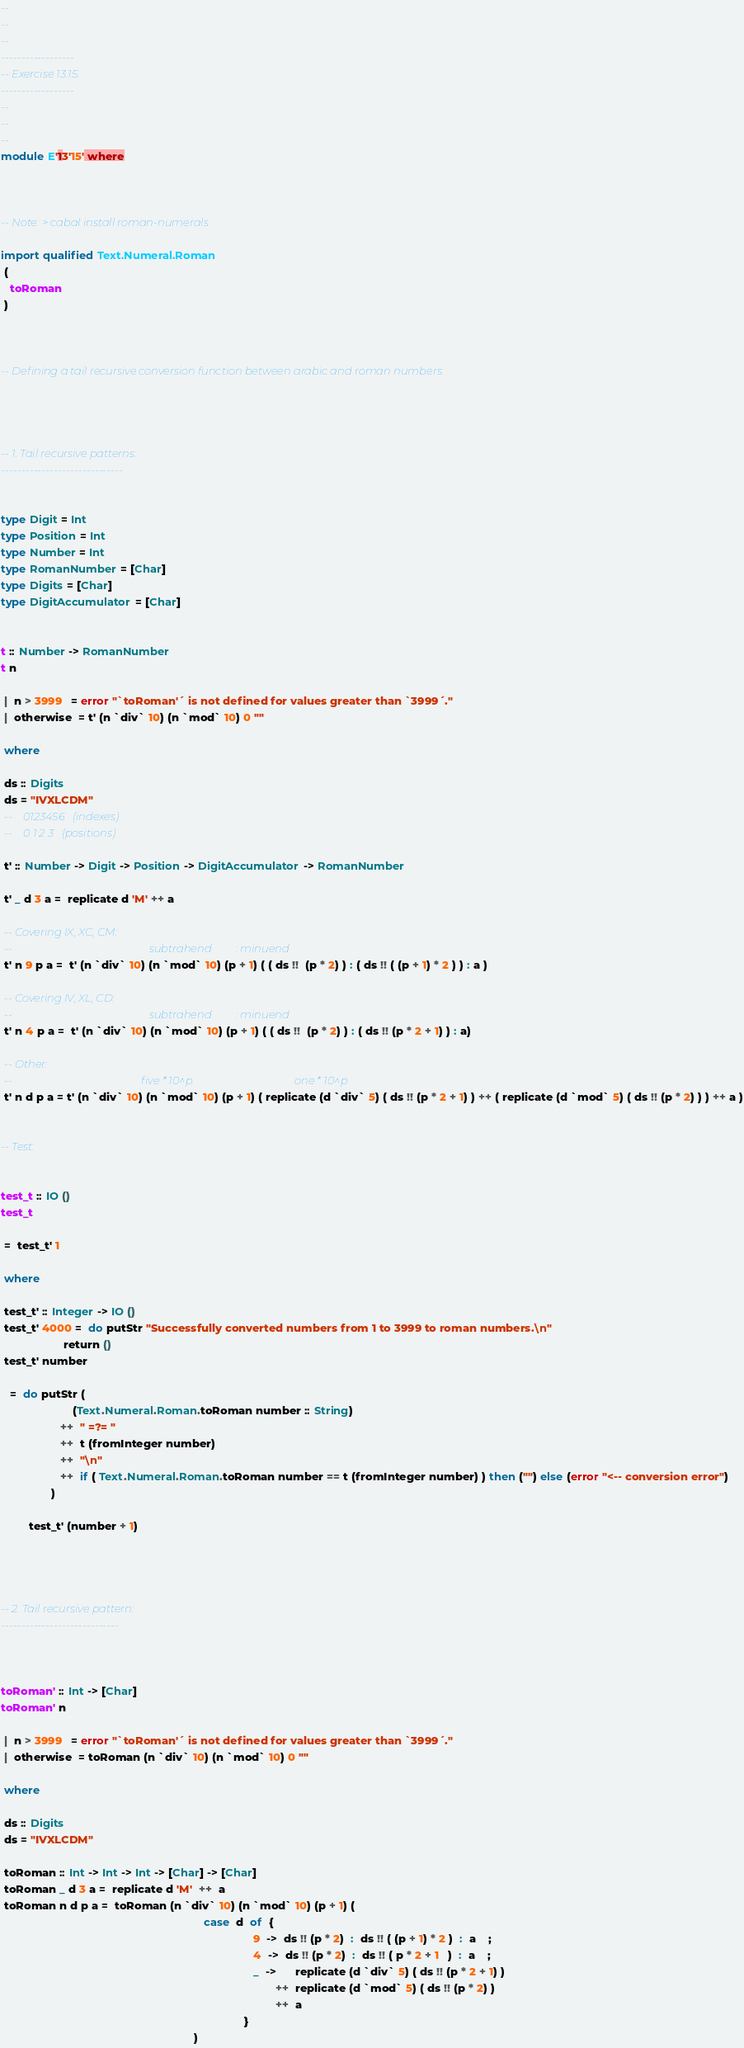<code> <loc_0><loc_0><loc_500><loc_500><_Haskell_>--
--
--
------------------
-- Exercise 13.15.
------------------
--
--
--
module E'13'15' where



-- Note: > cabal install roman-numerals

import qualified Text.Numeral.Roman
 (
   toRoman
 )



-- Defining a tail recursive conversion function between arabic and roman numbers.




-- 1. Tail recursive patterns:
------------------------------


type Digit = Int
type Position = Int
type Number = Int
type RomanNumber = [Char]
type Digits = [Char]
type DigitAccumulator = [Char]


t :: Number -> RomanNumber
t n

 |  n > 3999   = error "`toRoman'´ is not defined for values greater than `3999´."
 |  otherwise  = t' (n `div` 10) (n `mod` 10) 0 ""
 
 where
 
 ds :: Digits
 ds = "IVXLCDM"
 --    0123456   (indexes)
 --    0 1 2 3   (positions)
 
 t' :: Number -> Digit -> Position -> DigitAccumulator -> RomanNumber
 
 t' _ d 3 a =  replicate d 'M' ++ a
 
 -- Covering IX, XC, CM:
 --                                                   subtrahend         : minuend 
 t' n 9 p a =  t' (n `div` 10) (n `mod` 10) (p + 1) ( ( ds !!  (p * 2) ) : ( ds !! ( (p + 1) * 2 ) ) : a )
 
 -- Covering IV, XL, CD:
 --                                                   subtrahend         : minuend
 t' n 4 p a =  t' (n `div` 10) (n `mod` 10) (p + 1) ( ( ds !!  (p * 2) ) : ( ds !! (p * 2 + 1) ) : a)

 -- Other:
 --                                                five * 10^p                                      one * 10^p
 t' n d p a = t' (n `div` 10) (n `mod` 10) (p + 1) ( replicate (d `div` 5) ( ds !! (p * 2 + 1) ) ++ ( replicate (d `mod` 5) ( ds !! (p * 2) ) ) ++ a )


-- Test:


test_t :: IO ()
test_t

 =  test_t' 1
 
 where
 
 test_t' :: Integer -> IO ()
 test_t' 4000 =  do putStr "Successfully converted numbers from 1 to 3999 to roman numbers.\n"
                    return ()
 test_t' number
 
   =  do putStr (
                       (Text.Numeral.Roman.toRoman number :: String)
                   ++  " =?= "
			       ++  t (fromInteger number)
				   ++  "\n"
				   ++  if ( Text.Numeral.Roman.toRoman number == t (fromInteger number) ) then ("") else (error "<-- conversion error")
			    )
			   
         test_t' (number + 1)
 



-- 2. Tail recursive pattern:
-----------------------------



toRoman' :: Int -> [Char]
toRoman' n

 |  n > 3999   = error "`toRoman'´ is not defined for values greater than `3999´."
 |  otherwise  = toRoman (n `div` 10) (n `mod` 10) 0 ""
 
 where
 
 ds :: Digits
 ds = "IVXLCDM"
 
 toRoman :: Int -> Int -> Int -> [Char] -> [Char]
 toRoman _ d 3 a =  replicate d 'M'  ++  a
 toRoman n d p a =  toRoman (n `div` 10) (n `mod` 10) (p + 1) ( 
                                                                 case  d  of  { 
																	             9  ->  ds !! (p * 2)  :  ds !! ( (p + 1) * 2 )  :  a    ;
													                             4  ->  ds !! (p * 2)  :  ds !! ( p * 2 + 1   )  :  a    ;
																	             _  ->      replicate (d `div` 5) ( ds !! (p * 2 + 1) )
																	                    ++  replicate (d `mod` 5) ( ds !! (p * 2) )
																			            ++  a
																	          }
                                                              )




</code> 